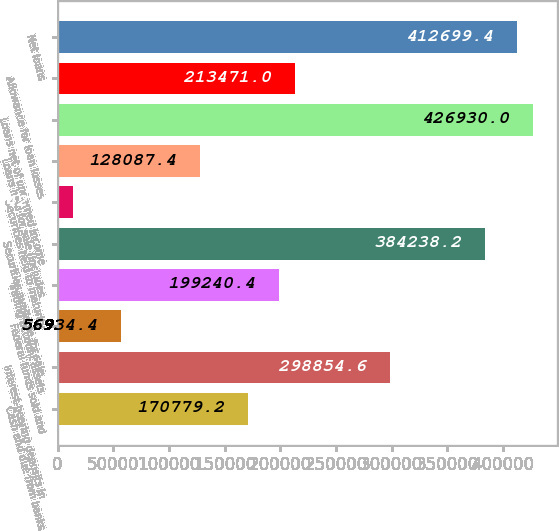<chart> <loc_0><loc_0><loc_500><loc_500><bar_chart><fcel>Cash and due from banks<fcel>Interest-bearing deposits in<fcel>Federal funds sold and<fcel>Trading account assets<fcel>Securities available for sale<fcel>Securities held to maturity<fcel>Loans held for sale (includes<fcel>Loans net of unearned income<fcel>Allowance for loan losses<fcel>Net loans<nl><fcel>170779<fcel>298855<fcel>56934.4<fcel>199240<fcel>384238<fcel>14242.6<fcel>128087<fcel>426930<fcel>213471<fcel>412699<nl></chart> 